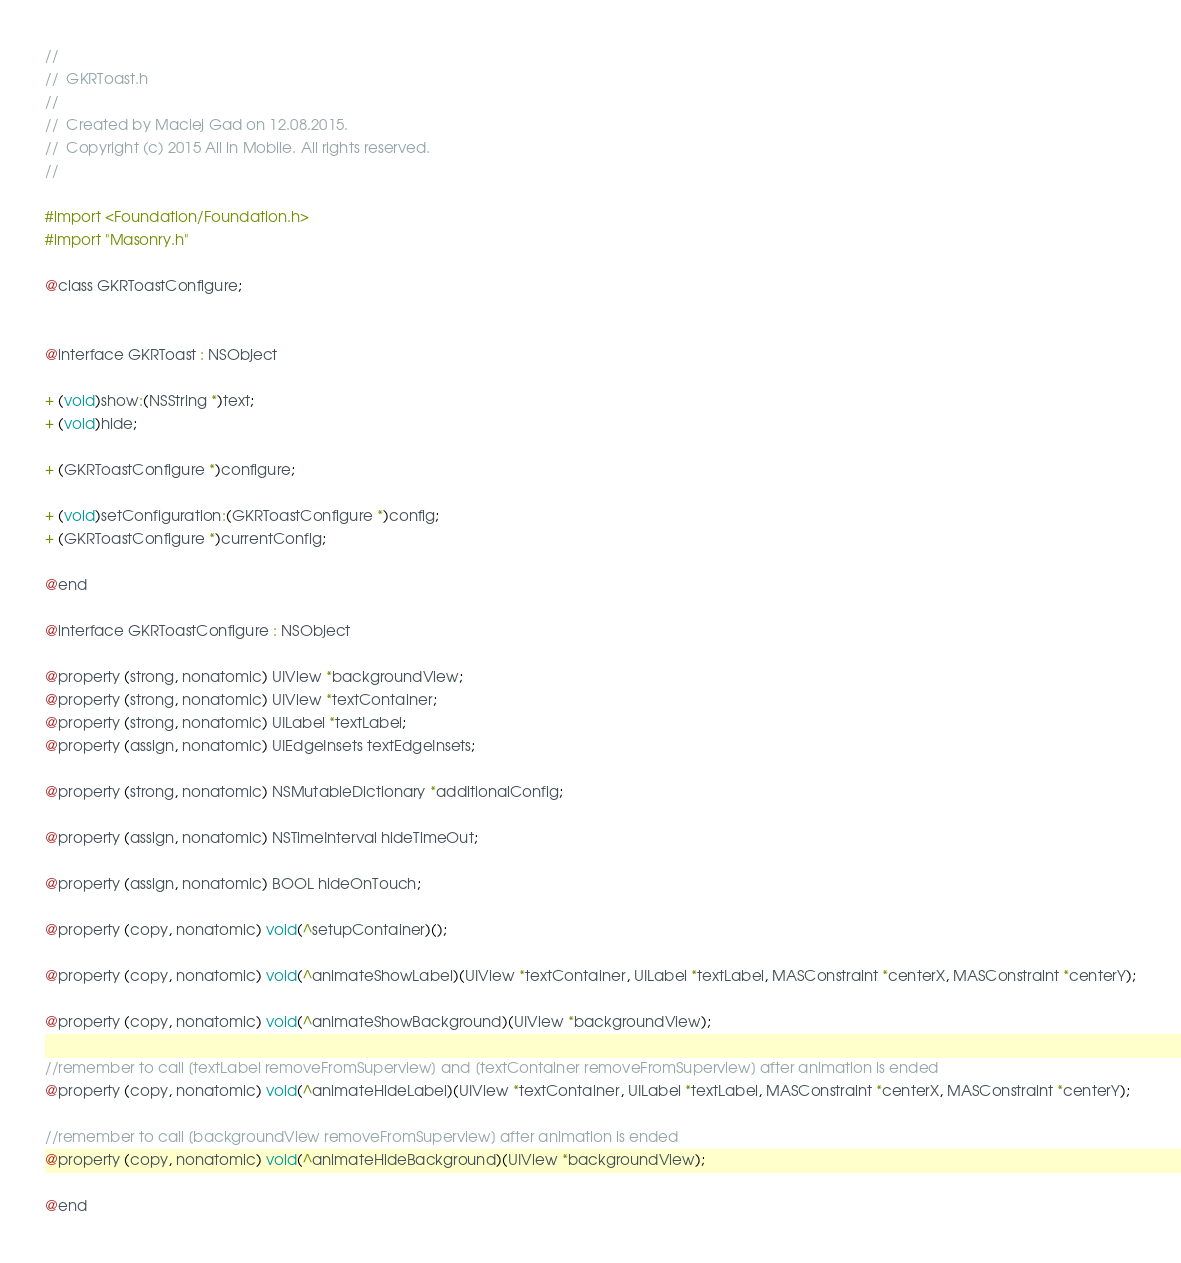Convert code to text. <code><loc_0><loc_0><loc_500><loc_500><_C_>//
//  GKRToast.h
//
//  Created by Maciej Gad on 12.08.2015.
//  Copyright (c) 2015 All in Mobile. All rights reserved.
//

#import <Foundation/Foundation.h>
#import "Masonry.h"

@class GKRToastConfigure;


@interface GKRToast : NSObject

+ (void)show:(NSString *)text;
+ (void)hide;

+ (GKRToastConfigure *)configure;

+ (void)setConfiguration:(GKRToastConfigure *)config;
+ (GKRToastConfigure *)currentConfig;

@end

@interface GKRToastConfigure : NSObject

@property (strong, nonatomic) UIView *backgroundView;
@property (strong, nonatomic) UIView *textContainer;
@property (strong, nonatomic) UILabel *textLabel;
@property (assign, nonatomic) UIEdgeInsets textEdgeInsets;

@property (strong, nonatomic) NSMutableDictionary *additionalConfig;

@property (assign, nonatomic) NSTimeInterval hideTimeOut;

@property (assign, nonatomic) BOOL hideOnTouch;

@property (copy, nonatomic) void(^setupContainer)();

@property (copy, nonatomic) void(^animateShowLabel)(UIView *textContainer, UILabel *textLabel, MASConstraint *centerX, MASConstraint *centerY);

@property (copy, nonatomic) void(^animateShowBackground)(UIView *backgroundView);

//remember to call [textLabel removeFromSuperview] and [textContainer removeFromSuperview] after animation is ended
@property (copy, nonatomic) void(^animateHideLabel)(UIView *textContainer, UILabel *textLabel, MASConstraint *centerX, MASConstraint *centerY);

//remember to call [backgroundView removeFromSuperview] after animation is ended
@property (copy, nonatomic) void(^animateHideBackground)(UIView *backgroundView);

@end
</code> 